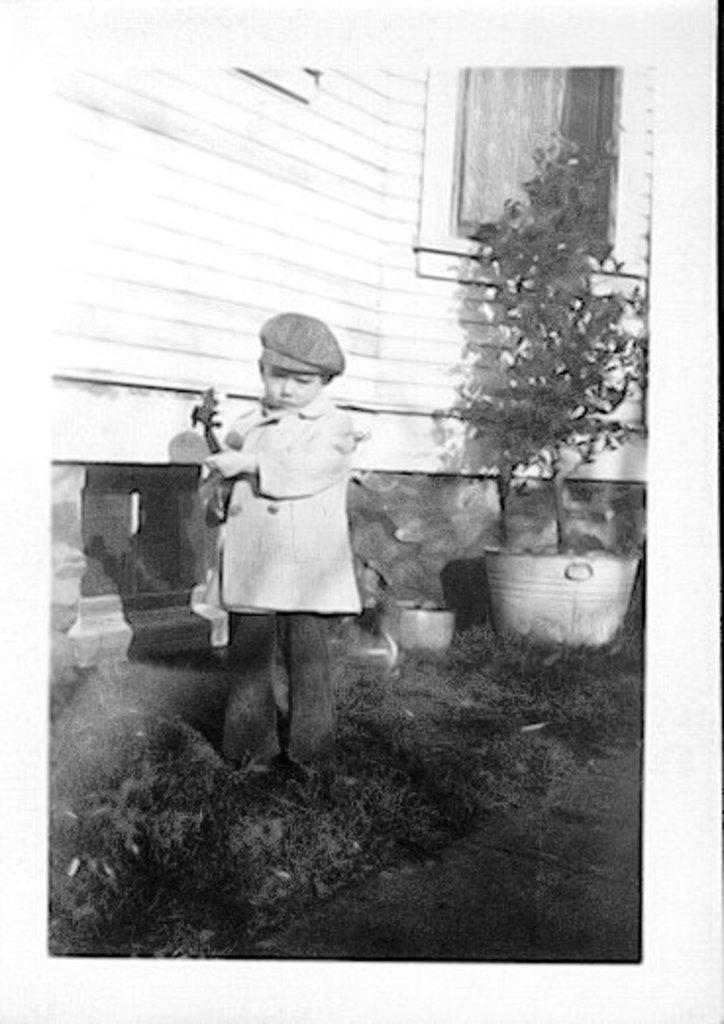How would you summarize this image in a sentence or two? This is a black and white picture. In this picture, we see a boy is standing and he is holding something in his hands. At the bottom, we see the grass and the pavement. Behind him, we see the plant pot. In the background, we see the wall in white color and we even see the window. This picture might be a photo frame. 